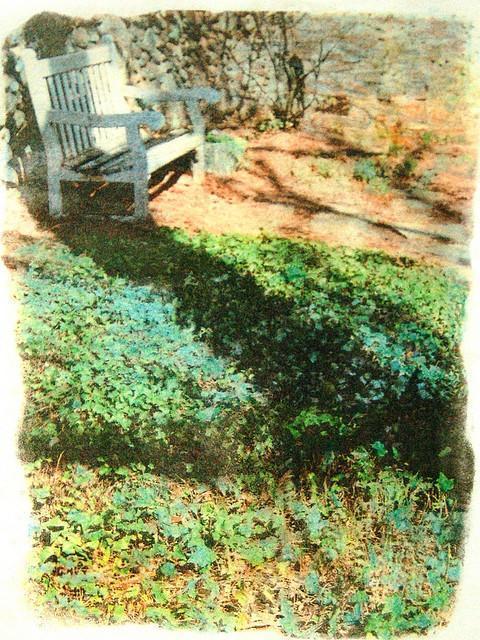How many people are jumping up?
Give a very brief answer. 0. 